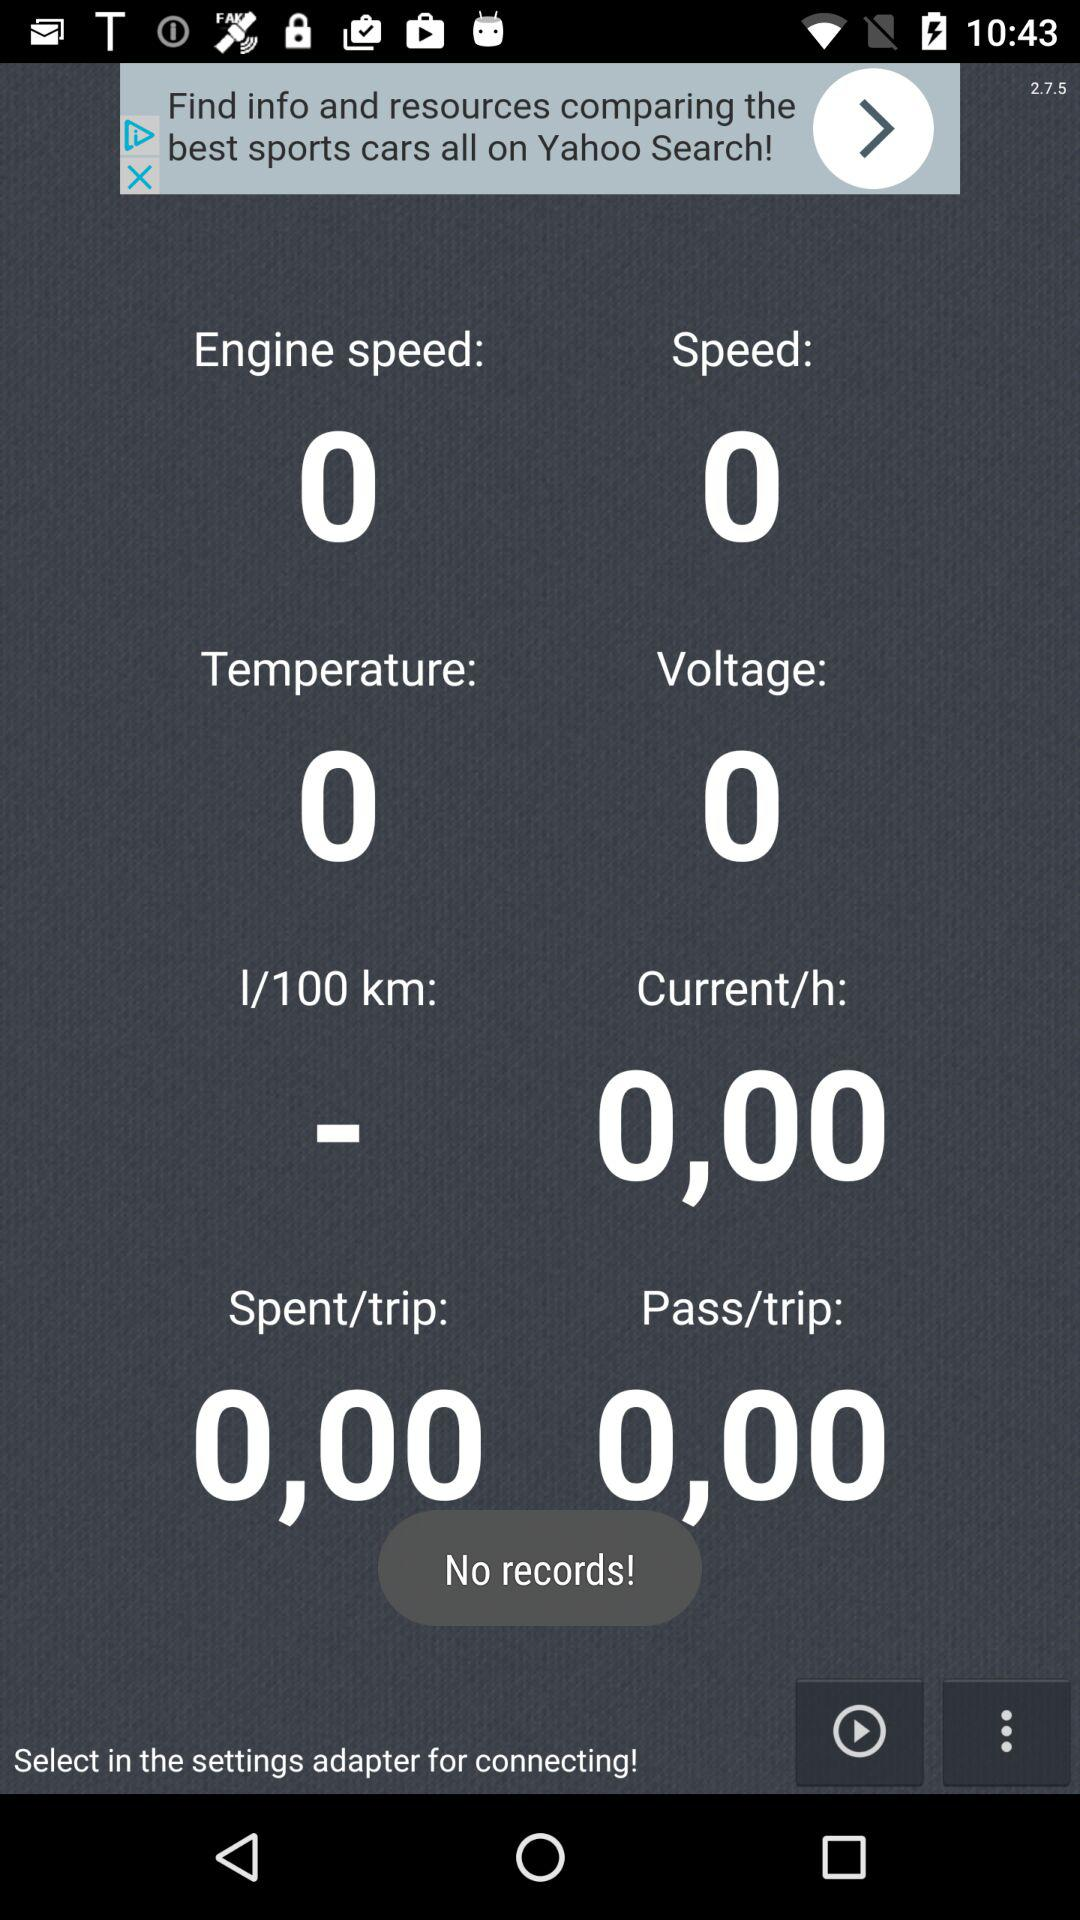What is the temperature? The temperature is 0. 